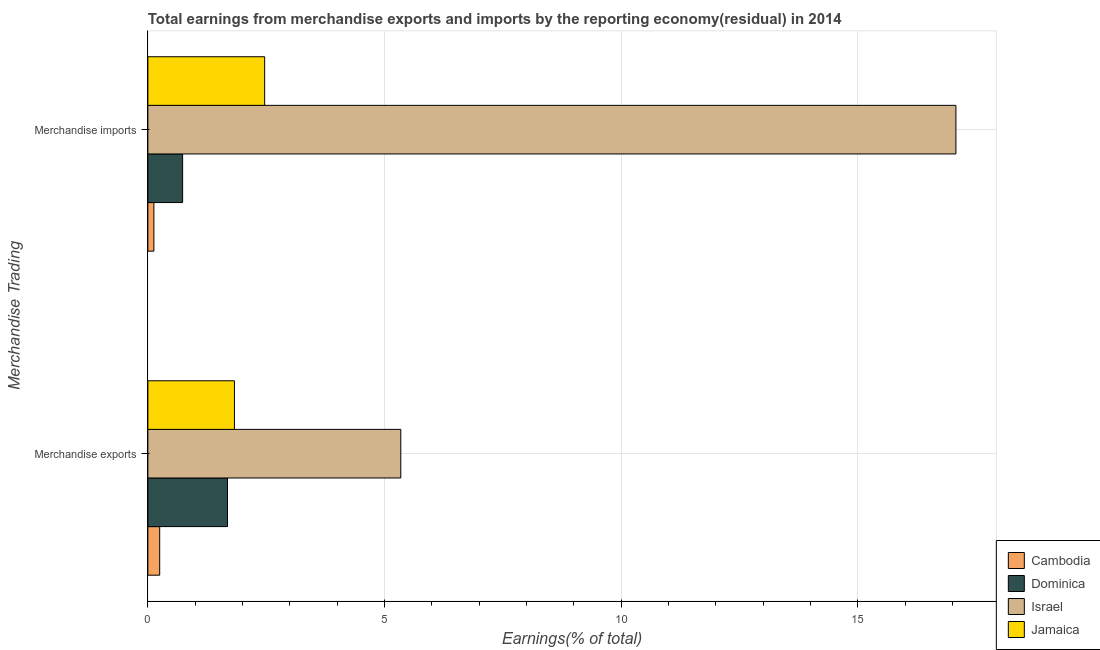How many different coloured bars are there?
Keep it short and to the point. 4. How many groups of bars are there?
Ensure brevity in your answer.  2. What is the label of the 1st group of bars from the top?
Make the answer very short. Merchandise imports. What is the earnings from merchandise exports in Jamaica?
Keep it short and to the point. 1.83. Across all countries, what is the maximum earnings from merchandise imports?
Provide a short and direct response. 17.07. Across all countries, what is the minimum earnings from merchandise imports?
Provide a succinct answer. 0.13. In which country was the earnings from merchandise exports maximum?
Make the answer very short. Israel. In which country was the earnings from merchandise imports minimum?
Keep it short and to the point. Cambodia. What is the total earnings from merchandise imports in the graph?
Ensure brevity in your answer.  20.4. What is the difference between the earnings from merchandise imports in Jamaica and that in Cambodia?
Offer a very short reply. 2.34. What is the difference between the earnings from merchandise imports in Jamaica and the earnings from merchandise exports in Cambodia?
Your answer should be compact. 2.22. What is the average earnings from merchandise imports per country?
Offer a terse response. 5.1. What is the difference between the earnings from merchandise imports and earnings from merchandise exports in Cambodia?
Offer a terse response. -0.12. In how many countries, is the earnings from merchandise imports greater than 3 %?
Provide a short and direct response. 1. What is the ratio of the earnings from merchandise imports in Israel to that in Cambodia?
Ensure brevity in your answer.  133.99. In how many countries, is the earnings from merchandise exports greater than the average earnings from merchandise exports taken over all countries?
Offer a very short reply. 1. What does the 4th bar from the bottom in Merchandise exports represents?
Offer a very short reply. Jamaica. How many bars are there?
Provide a succinct answer. 8. Are all the bars in the graph horizontal?
Ensure brevity in your answer.  Yes. How many countries are there in the graph?
Provide a succinct answer. 4. Does the graph contain any zero values?
Your response must be concise. No. Does the graph contain grids?
Your response must be concise. Yes. Where does the legend appear in the graph?
Keep it short and to the point. Bottom right. How many legend labels are there?
Offer a very short reply. 4. How are the legend labels stacked?
Provide a succinct answer. Vertical. What is the title of the graph?
Provide a short and direct response. Total earnings from merchandise exports and imports by the reporting economy(residual) in 2014. What is the label or title of the X-axis?
Keep it short and to the point. Earnings(% of total). What is the label or title of the Y-axis?
Make the answer very short. Merchandise Trading. What is the Earnings(% of total) in Cambodia in Merchandise exports?
Your answer should be compact. 0.25. What is the Earnings(% of total) in Dominica in Merchandise exports?
Provide a succinct answer. 1.68. What is the Earnings(% of total) in Israel in Merchandise exports?
Your response must be concise. 5.34. What is the Earnings(% of total) in Jamaica in Merchandise exports?
Offer a terse response. 1.83. What is the Earnings(% of total) in Cambodia in Merchandise imports?
Ensure brevity in your answer.  0.13. What is the Earnings(% of total) of Dominica in Merchandise imports?
Offer a terse response. 0.73. What is the Earnings(% of total) in Israel in Merchandise imports?
Provide a succinct answer. 17.07. What is the Earnings(% of total) in Jamaica in Merchandise imports?
Your response must be concise. 2.47. Across all Merchandise Trading, what is the maximum Earnings(% of total) in Cambodia?
Provide a succinct answer. 0.25. Across all Merchandise Trading, what is the maximum Earnings(% of total) of Dominica?
Your answer should be compact. 1.68. Across all Merchandise Trading, what is the maximum Earnings(% of total) of Israel?
Make the answer very short. 17.07. Across all Merchandise Trading, what is the maximum Earnings(% of total) in Jamaica?
Provide a succinct answer. 2.47. Across all Merchandise Trading, what is the minimum Earnings(% of total) in Cambodia?
Give a very brief answer. 0.13. Across all Merchandise Trading, what is the minimum Earnings(% of total) of Dominica?
Keep it short and to the point. 0.73. Across all Merchandise Trading, what is the minimum Earnings(% of total) in Israel?
Provide a succinct answer. 5.34. Across all Merchandise Trading, what is the minimum Earnings(% of total) in Jamaica?
Offer a very short reply. 1.83. What is the total Earnings(% of total) of Cambodia in the graph?
Your answer should be compact. 0.38. What is the total Earnings(% of total) in Dominica in the graph?
Your response must be concise. 2.42. What is the total Earnings(% of total) of Israel in the graph?
Your response must be concise. 22.42. What is the total Earnings(% of total) of Jamaica in the graph?
Your answer should be compact. 4.3. What is the difference between the Earnings(% of total) in Cambodia in Merchandise exports and that in Merchandise imports?
Your answer should be compact. 0.12. What is the difference between the Earnings(% of total) in Dominica in Merchandise exports and that in Merchandise imports?
Offer a very short reply. 0.95. What is the difference between the Earnings(% of total) in Israel in Merchandise exports and that in Merchandise imports?
Give a very brief answer. -11.73. What is the difference between the Earnings(% of total) of Jamaica in Merchandise exports and that in Merchandise imports?
Your answer should be very brief. -0.64. What is the difference between the Earnings(% of total) in Cambodia in Merchandise exports and the Earnings(% of total) in Dominica in Merchandise imports?
Provide a succinct answer. -0.48. What is the difference between the Earnings(% of total) of Cambodia in Merchandise exports and the Earnings(% of total) of Israel in Merchandise imports?
Your response must be concise. -16.82. What is the difference between the Earnings(% of total) in Cambodia in Merchandise exports and the Earnings(% of total) in Jamaica in Merchandise imports?
Your answer should be very brief. -2.22. What is the difference between the Earnings(% of total) in Dominica in Merchandise exports and the Earnings(% of total) in Israel in Merchandise imports?
Offer a very short reply. -15.39. What is the difference between the Earnings(% of total) in Dominica in Merchandise exports and the Earnings(% of total) in Jamaica in Merchandise imports?
Provide a short and direct response. -0.78. What is the difference between the Earnings(% of total) in Israel in Merchandise exports and the Earnings(% of total) in Jamaica in Merchandise imports?
Provide a short and direct response. 2.88. What is the average Earnings(% of total) in Cambodia per Merchandise Trading?
Your response must be concise. 0.19. What is the average Earnings(% of total) in Dominica per Merchandise Trading?
Keep it short and to the point. 1.21. What is the average Earnings(% of total) in Israel per Merchandise Trading?
Make the answer very short. 11.21. What is the average Earnings(% of total) in Jamaica per Merchandise Trading?
Provide a short and direct response. 2.15. What is the difference between the Earnings(% of total) of Cambodia and Earnings(% of total) of Dominica in Merchandise exports?
Your response must be concise. -1.43. What is the difference between the Earnings(% of total) in Cambodia and Earnings(% of total) in Israel in Merchandise exports?
Your answer should be compact. -5.09. What is the difference between the Earnings(% of total) in Cambodia and Earnings(% of total) in Jamaica in Merchandise exports?
Your response must be concise. -1.58. What is the difference between the Earnings(% of total) of Dominica and Earnings(% of total) of Israel in Merchandise exports?
Keep it short and to the point. -3.66. What is the difference between the Earnings(% of total) in Dominica and Earnings(% of total) in Jamaica in Merchandise exports?
Your response must be concise. -0.15. What is the difference between the Earnings(% of total) of Israel and Earnings(% of total) of Jamaica in Merchandise exports?
Offer a terse response. 3.52. What is the difference between the Earnings(% of total) of Cambodia and Earnings(% of total) of Dominica in Merchandise imports?
Provide a succinct answer. -0.61. What is the difference between the Earnings(% of total) of Cambodia and Earnings(% of total) of Israel in Merchandise imports?
Your answer should be compact. -16.95. What is the difference between the Earnings(% of total) of Cambodia and Earnings(% of total) of Jamaica in Merchandise imports?
Offer a terse response. -2.34. What is the difference between the Earnings(% of total) in Dominica and Earnings(% of total) in Israel in Merchandise imports?
Provide a succinct answer. -16.34. What is the difference between the Earnings(% of total) of Dominica and Earnings(% of total) of Jamaica in Merchandise imports?
Give a very brief answer. -1.73. What is the difference between the Earnings(% of total) of Israel and Earnings(% of total) of Jamaica in Merchandise imports?
Offer a very short reply. 14.61. What is the ratio of the Earnings(% of total) in Cambodia in Merchandise exports to that in Merchandise imports?
Offer a terse response. 1.96. What is the ratio of the Earnings(% of total) of Dominica in Merchandise exports to that in Merchandise imports?
Offer a very short reply. 2.29. What is the ratio of the Earnings(% of total) of Israel in Merchandise exports to that in Merchandise imports?
Provide a succinct answer. 0.31. What is the ratio of the Earnings(% of total) of Jamaica in Merchandise exports to that in Merchandise imports?
Make the answer very short. 0.74. What is the difference between the highest and the second highest Earnings(% of total) of Cambodia?
Offer a terse response. 0.12. What is the difference between the highest and the second highest Earnings(% of total) of Dominica?
Provide a succinct answer. 0.95. What is the difference between the highest and the second highest Earnings(% of total) of Israel?
Your answer should be very brief. 11.73. What is the difference between the highest and the second highest Earnings(% of total) of Jamaica?
Your answer should be compact. 0.64. What is the difference between the highest and the lowest Earnings(% of total) in Cambodia?
Offer a terse response. 0.12. What is the difference between the highest and the lowest Earnings(% of total) of Dominica?
Your answer should be compact. 0.95. What is the difference between the highest and the lowest Earnings(% of total) in Israel?
Provide a short and direct response. 11.73. What is the difference between the highest and the lowest Earnings(% of total) of Jamaica?
Offer a very short reply. 0.64. 